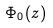Convert formula to latex. <formula><loc_0><loc_0><loc_500><loc_500>\Phi _ { 0 } ( z )</formula> 